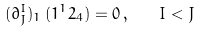<formula> <loc_0><loc_0><loc_500><loc_500>( \partial ^ { I } _ { J } ) _ { 1 } \, ( 1 ^ { 1 } 2 _ { 4 } ) = 0 \, , \quad I < J</formula> 